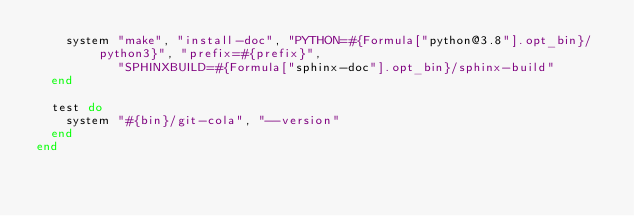<code> <loc_0><loc_0><loc_500><loc_500><_Ruby_>    system "make", "install-doc", "PYTHON=#{Formula["python@3.8"].opt_bin}/python3}", "prefix=#{prefix}",
           "SPHINXBUILD=#{Formula["sphinx-doc"].opt_bin}/sphinx-build"
  end

  test do
    system "#{bin}/git-cola", "--version"
  end
end
</code> 